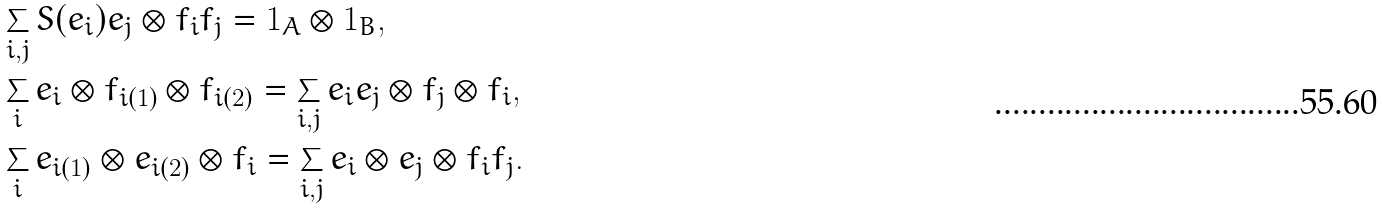Convert formula to latex. <formula><loc_0><loc_0><loc_500><loc_500>& \sum _ { i , j } S ( e _ { i } ) e _ { j } \otimes f _ { i } f _ { j } = 1 _ { A } \otimes 1 _ { B } , \\ & \sum _ { i } e _ { i } \otimes f _ { i ( 1 ) } \otimes f _ { i ( 2 ) } = \sum _ { i , j } e _ { i } e _ { j } \otimes f _ { j } \otimes f _ { i } , \\ & \sum _ { i } e _ { i ( 1 ) } \otimes e _ { i ( 2 ) } \otimes f _ { i } = \sum _ { i , j } e _ { i } \otimes e _ { j } \otimes f _ { i } f _ { j } .</formula> 